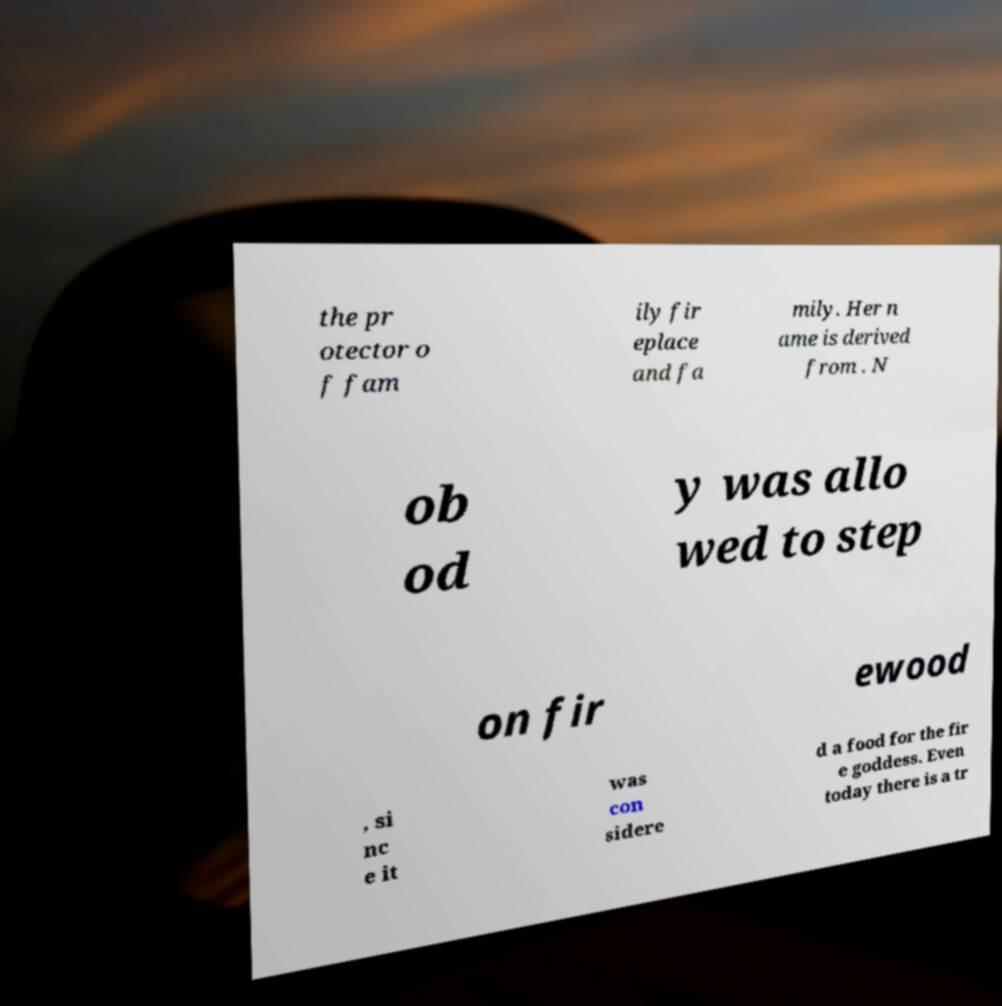I need the written content from this picture converted into text. Can you do that? the pr otector o f fam ily fir eplace and fa mily. Her n ame is derived from . N ob od y was allo wed to step on fir ewood , si nc e it was con sidere d a food for the fir e goddess. Even today there is a tr 